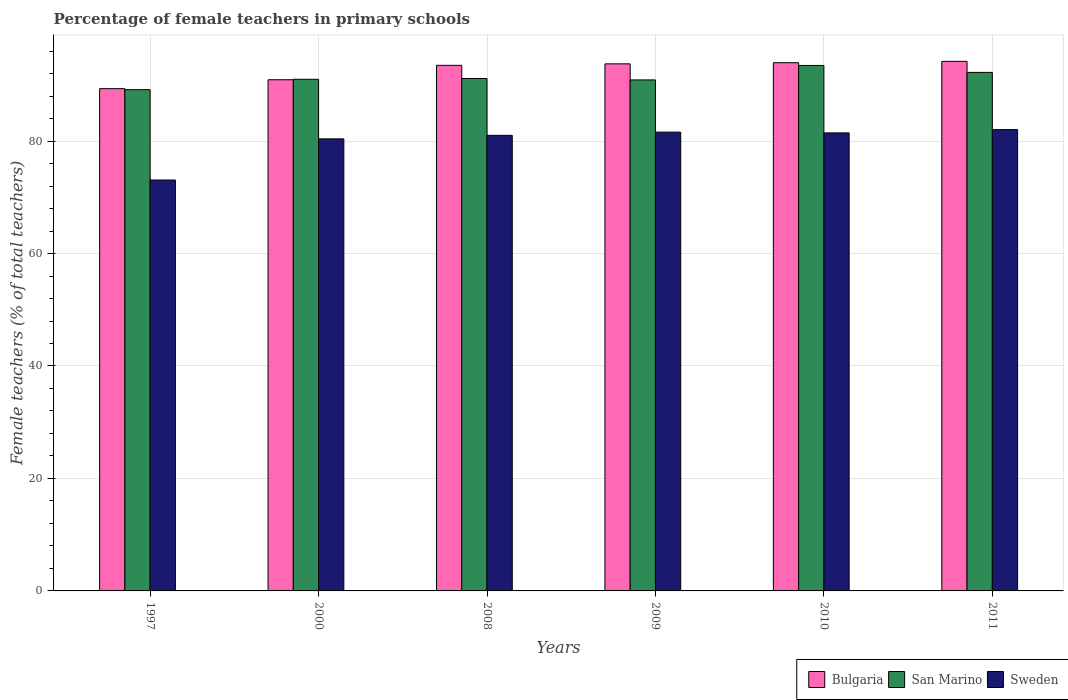Are the number of bars per tick equal to the number of legend labels?
Your answer should be compact. Yes. Are the number of bars on each tick of the X-axis equal?
Your answer should be very brief. Yes. How many bars are there on the 1st tick from the left?
Give a very brief answer. 3. What is the percentage of female teachers in Sweden in 1997?
Your answer should be compact. 73.07. Across all years, what is the maximum percentage of female teachers in Bulgaria?
Provide a succinct answer. 94.17. Across all years, what is the minimum percentage of female teachers in San Marino?
Ensure brevity in your answer.  89.14. In which year was the percentage of female teachers in Bulgaria maximum?
Offer a very short reply. 2011. In which year was the percentage of female teachers in Bulgaria minimum?
Your answer should be compact. 1997. What is the total percentage of female teachers in San Marino in the graph?
Offer a very short reply. 547.79. What is the difference between the percentage of female teachers in Sweden in 2010 and that in 2011?
Give a very brief answer. -0.58. What is the difference between the percentage of female teachers in Bulgaria in 1997 and the percentage of female teachers in Sweden in 2009?
Make the answer very short. 7.73. What is the average percentage of female teachers in Sweden per year?
Provide a short and direct response. 79.93. In the year 2011, what is the difference between the percentage of female teachers in San Marino and percentage of female teachers in Sweden?
Offer a very short reply. 10.18. In how many years, is the percentage of female teachers in San Marino greater than 64 %?
Ensure brevity in your answer.  6. What is the ratio of the percentage of female teachers in Sweden in 1997 to that in 2000?
Provide a succinct answer. 0.91. Is the percentage of female teachers in Bulgaria in 2000 less than that in 2009?
Provide a short and direct response. Yes. Is the difference between the percentage of female teachers in San Marino in 2000 and 2011 greater than the difference between the percentage of female teachers in Sweden in 2000 and 2011?
Your answer should be very brief. Yes. What is the difference between the highest and the second highest percentage of female teachers in Bulgaria?
Keep it short and to the point. 0.24. What is the difference between the highest and the lowest percentage of female teachers in San Marino?
Your answer should be very brief. 4.3. What does the 1st bar from the left in 2009 represents?
Make the answer very short. Bulgaria. Is it the case that in every year, the sum of the percentage of female teachers in San Marino and percentage of female teachers in Bulgaria is greater than the percentage of female teachers in Sweden?
Give a very brief answer. Yes. How many bars are there?
Provide a short and direct response. 18. What is the difference between two consecutive major ticks on the Y-axis?
Provide a short and direct response. 20. Does the graph contain any zero values?
Give a very brief answer. No. Does the graph contain grids?
Your answer should be compact. Yes. How many legend labels are there?
Keep it short and to the point. 3. How are the legend labels stacked?
Make the answer very short. Horizontal. What is the title of the graph?
Offer a very short reply. Percentage of female teachers in primary schools. What is the label or title of the X-axis?
Your answer should be compact. Years. What is the label or title of the Y-axis?
Give a very brief answer. Female teachers (% of total teachers). What is the Female teachers (% of total teachers) of Bulgaria in 1997?
Provide a succinct answer. 89.32. What is the Female teachers (% of total teachers) of San Marino in 1997?
Your answer should be very brief. 89.14. What is the Female teachers (% of total teachers) in Sweden in 1997?
Make the answer very short. 73.07. What is the Female teachers (% of total teachers) in Bulgaria in 2000?
Ensure brevity in your answer.  90.91. What is the Female teachers (% of total teachers) in San Marino in 2000?
Provide a succinct answer. 90.99. What is the Female teachers (% of total teachers) in Sweden in 2000?
Give a very brief answer. 80.39. What is the Female teachers (% of total teachers) of Bulgaria in 2008?
Give a very brief answer. 93.47. What is the Female teachers (% of total teachers) of San Marino in 2008?
Keep it short and to the point. 91.13. What is the Female teachers (% of total teachers) of Sweden in 2008?
Your answer should be very brief. 81.01. What is the Female teachers (% of total teachers) of Bulgaria in 2009?
Your response must be concise. 93.73. What is the Female teachers (% of total teachers) of San Marino in 2009?
Your answer should be compact. 90.87. What is the Female teachers (% of total teachers) of Sweden in 2009?
Your answer should be very brief. 81.59. What is the Female teachers (% of total teachers) of Bulgaria in 2010?
Make the answer very short. 93.93. What is the Female teachers (% of total teachers) in San Marino in 2010?
Your answer should be compact. 93.44. What is the Female teachers (% of total teachers) in Sweden in 2010?
Offer a terse response. 81.45. What is the Female teachers (% of total teachers) of Bulgaria in 2011?
Your answer should be compact. 94.17. What is the Female teachers (% of total teachers) in San Marino in 2011?
Your response must be concise. 92.21. What is the Female teachers (% of total teachers) of Sweden in 2011?
Provide a short and direct response. 82.04. Across all years, what is the maximum Female teachers (% of total teachers) in Bulgaria?
Ensure brevity in your answer.  94.17. Across all years, what is the maximum Female teachers (% of total teachers) in San Marino?
Provide a succinct answer. 93.44. Across all years, what is the maximum Female teachers (% of total teachers) in Sweden?
Offer a terse response. 82.04. Across all years, what is the minimum Female teachers (% of total teachers) in Bulgaria?
Ensure brevity in your answer.  89.32. Across all years, what is the minimum Female teachers (% of total teachers) in San Marino?
Offer a very short reply. 89.14. Across all years, what is the minimum Female teachers (% of total teachers) of Sweden?
Your answer should be very brief. 73.07. What is the total Female teachers (% of total teachers) of Bulgaria in the graph?
Your answer should be very brief. 555.53. What is the total Female teachers (% of total teachers) in San Marino in the graph?
Ensure brevity in your answer.  547.79. What is the total Female teachers (% of total teachers) of Sweden in the graph?
Your answer should be compact. 479.56. What is the difference between the Female teachers (% of total teachers) in Bulgaria in 1997 and that in 2000?
Offer a terse response. -1.59. What is the difference between the Female teachers (% of total teachers) in San Marino in 1997 and that in 2000?
Offer a very short reply. -1.85. What is the difference between the Female teachers (% of total teachers) in Sweden in 1997 and that in 2000?
Your answer should be very brief. -7.32. What is the difference between the Female teachers (% of total teachers) in Bulgaria in 1997 and that in 2008?
Make the answer very short. -4.15. What is the difference between the Female teachers (% of total teachers) in San Marino in 1997 and that in 2008?
Make the answer very short. -1.99. What is the difference between the Female teachers (% of total teachers) of Sweden in 1997 and that in 2008?
Offer a very short reply. -7.94. What is the difference between the Female teachers (% of total teachers) in Bulgaria in 1997 and that in 2009?
Offer a very short reply. -4.41. What is the difference between the Female teachers (% of total teachers) in San Marino in 1997 and that in 2009?
Ensure brevity in your answer.  -1.73. What is the difference between the Female teachers (% of total teachers) of Sweden in 1997 and that in 2009?
Your response must be concise. -8.52. What is the difference between the Female teachers (% of total teachers) of Bulgaria in 1997 and that in 2010?
Ensure brevity in your answer.  -4.61. What is the difference between the Female teachers (% of total teachers) of San Marino in 1997 and that in 2010?
Keep it short and to the point. -4.3. What is the difference between the Female teachers (% of total teachers) in Sweden in 1997 and that in 2010?
Provide a short and direct response. -8.38. What is the difference between the Female teachers (% of total teachers) in Bulgaria in 1997 and that in 2011?
Offer a terse response. -4.86. What is the difference between the Female teachers (% of total teachers) in San Marino in 1997 and that in 2011?
Offer a terse response. -3.07. What is the difference between the Female teachers (% of total teachers) in Sweden in 1997 and that in 2011?
Offer a very short reply. -8.96. What is the difference between the Female teachers (% of total teachers) of Bulgaria in 2000 and that in 2008?
Provide a succinct answer. -2.56. What is the difference between the Female teachers (% of total teachers) of San Marino in 2000 and that in 2008?
Your response must be concise. -0.14. What is the difference between the Female teachers (% of total teachers) of Sweden in 2000 and that in 2008?
Make the answer very short. -0.62. What is the difference between the Female teachers (% of total teachers) in Bulgaria in 2000 and that in 2009?
Ensure brevity in your answer.  -2.83. What is the difference between the Female teachers (% of total teachers) in San Marino in 2000 and that in 2009?
Your answer should be compact. 0.11. What is the difference between the Female teachers (% of total teachers) in Sweden in 2000 and that in 2009?
Ensure brevity in your answer.  -1.2. What is the difference between the Female teachers (% of total teachers) in Bulgaria in 2000 and that in 2010?
Keep it short and to the point. -3.03. What is the difference between the Female teachers (% of total teachers) in San Marino in 2000 and that in 2010?
Offer a terse response. -2.46. What is the difference between the Female teachers (% of total teachers) of Sweden in 2000 and that in 2010?
Offer a very short reply. -1.06. What is the difference between the Female teachers (% of total teachers) in Bulgaria in 2000 and that in 2011?
Ensure brevity in your answer.  -3.27. What is the difference between the Female teachers (% of total teachers) in San Marino in 2000 and that in 2011?
Your response must be concise. -1.23. What is the difference between the Female teachers (% of total teachers) in Sweden in 2000 and that in 2011?
Offer a very short reply. -1.65. What is the difference between the Female teachers (% of total teachers) in Bulgaria in 2008 and that in 2009?
Ensure brevity in your answer.  -0.27. What is the difference between the Female teachers (% of total teachers) of San Marino in 2008 and that in 2009?
Your answer should be compact. 0.26. What is the difference between the Female teachers (% of total teachers) of Sweden in 2008 and that in 2009?
Provide a succinct answer. -0.57. What is the difference between the Female teachers (% of total teachers) of Bulgaria in 2008 and that in 2010?
Offer a very short reply. -0.47. What is the difference between the Female teachers (% of total teachers) in San Marino in 2008 and that in 2010?
Provide a short and direct response. -2.31. What is the difference between the Female teachers (% of total teachers) of Sweden in 2008 and that in 2010?
Offer a terse response. -0.44. What is the difference between the Female teachers (% of total teachers) in Bulgaria in 2008 and that in 2011?
Give a very brief answer. -0.71. What is the difference between the Female teachers (% of total teachers) of San Marino in 2008 and that in 2011?
Provide a short and direct response. -1.08. What is the difference between the Female teachers (% of total teachers) in Sweden in 2008 and that in 2011?
Your response must be concise. -1.02. What is the difference between the Female teachers (% of total teachers) of Bulgaria in 2009 and that in 2010?
Make the answer very short. -0.2. What is the difference between the Female teachers (% of total teachers) of San Marino in 2009 and that in 2010?
Your answer should be compact. -2.57. What is the difference between the Female teachers (% of total teachers) of Sweden in 2009 and that in 2010?
Provide a short and direct response. 0.14. What is the difference between the Female teachers (% of total teachers) of Bulgaria in 2009 and that in 2011?
Your answer should be very brief. -0.44. What is the difference between the Female teachers (% of total teachers) of San Marino in 2009 and that in 2011?
Provide a succinct answer. -1.34. What is the difference between the Female teachers (% of total teachers) of Sweden in 2009 and that in 2011?
Provide a short and direct response. -0.45. What is the difference between the Female teachers (% of total teachers) in Bulgaria in 2010 and that in 2011?
Your answer should be very brief. -0.24. What is the difference between the Female teachers (% of total teachers) of San Marino in 2010 and that in 2011?
Your response must be concise. 1.23. What is the difference between the Female teachers (% of total teachers) of Sweden in 2010 and that in 2011?
Provide a short and direct response. -0.58. What is the difference between the Female teachers (% of total teachers) in Bulgaria in 1997 and the Female teachers (% of total teachers) in San Marino in 2000?
Keep it short and to the point. -1.67. What is the difference between the Female teachers (% of total teachers) of Bulgaria in 1997 and the Female teachers (% of total teachers) of Sweden in 2000?
Provide a succinct answer. 8.93. What is the difference between the Female teachers (% of total teachers) in San Marino in 1997 and the Female teachers (% of total teachers) in Sweden in 2000?
Ensure brevity in your answer.  8.75. What is the difference between the Female teachers (% of total teachers) in Bulgaria in 1997 and the Female teachers (% of total teachers) in San Marino in 2008?
Keep it short and to the point. -1.81. What is the difference between the Female teachers (% of total teachers) in Bulgaria in 1997 and the Female teachers (% of total teachers) in Sweden in 2008?
Your answer should be very brief. 8.3. What is the difference between the Female teachers (% of total teachers) in San Marino in 1997 and the Female teachers (% of total teachers) in Sweden in 2008?
Make the answer very short. 8.13. What is the difference between the Female teachers (% of total teachers) of Bulgaria in 1997 and the Female teachers (% of total teachers) of San Marino in 2009?
Provide a short and direct response. -1.55. What is the difference between the Female teachers (% of total teachers) in Bulgaria in 1997 and the Female teachers (% of total teachers) in Sweden in 2009?
Make the answer very short. 7.73. What is the difference between the Female teachers (% of total teachers) in San Marino in 1997 and the Female teachers (% of total teachers) in Sweden in 2009?
Offer a terse response. 7.55. What is the difference between the Female teachers (% of total teachers) of Bulgaria in 1997 and the Female teachers (% of total teachers) of San Marino in 2010?
Your answer should be compact. -4.12. What is the difference between the Female teachers (% of total teachers) of Bulgaria in 1997 and the Female teachers (% of total teachers) of Sweden in 2010?
Provide a succinct answer. 7.87. What is the difference between the Female teachers (% of total teachers) in San Marino in 1997 and the Female teachers (% of total teachers) in Sweden in 2010?
Make the answer very short. 7.69. What is the difference between the Female teachers (% of total teachers) in Bulgaria in 1997 and the Female teachers (% of total teachers) in San Marino in 2011?
Your answer should be very brief. -2.89. What is the difference between the Female teachers (% of total teachers) in Bulgaria in 1997 and the Female teachers (% of total teachers) in Sweden in 2011?
Keep it short and to the point. 7.28. What is the difference between the Female teachers (% of total teachers) in San Marino in 1997 and the Female teachers (% of total teachers) in Sweden in 2011?
Ensure brevity in your answer.  7.1. What is the difference between the Female teachers (% of total teachers) of Bulgaria in 2000 and the Female teachers (% of total teachers) of San Marino in 2008?
Give a very brief answer. -0.22. What is the difference between the Female teachers (% of total teachers) in Bulgaria in 2000 and the Female teachers (% of total teachers) in Sweden in 2008?
Provide a short and direct response. 9.89. What is the difference between the Female teachers (% of total teachers) of San Marino in 2000 and the Female teachers (% of total teachers) of Sweden in 2008?
Your response must be concise. 9.97. What is the difference between the Female teachers (% of total teachers) in Bulgaria in 2000 and the Female teachers (% of total teachers) in San Marino in 2009?
Your answer should be compact. 0.03. What is the difference between the Female teachers (% of total teachers) of Bulgaria in 2000 and the Female teachers (% of total teachers) of Sweden in 2009?
Your answer should be very brief. 9.32. What is the difference between the Female teachers (% of total teachers) in San Marino in 2000 and the Female teachers (% of total teachers) in Sweden in 2009?
Ensure brevity in your answer.  9.4. What is the difference between the Female teachers (% of total teachers) in Bulgaria in 2000 and the Female teachers (% of total teachers) in San Marino in 2010?
Offer a terse response. -2.54. What is the difference between the Female teachers (% of total teachers) in Bulgaria in 2000 and the Female teachers (% of total teachers) in Sweden in 2010?
Your answer should be very brief. 9.45. What is the difference between the Female teachers (% of total teachers) of San Marino in 2000 and the Female teachers (% of total teachers) of Sweden in 2010?
Offer a terse response. 9.53. What is the difference between the Female teachers (% of total teachers) in Bulgaria in 2000 and the Female teachers (% of total teachers) in San Marino in 2011?
Your answer should be very brief. -1.31. What is the difference between the Female teachers (% of total teachers) in Bulgaria in 2000 and the Female teachers (% of total teachers) in Sweden in 2011?
Your answer should be compact. 8.87. What is the difference between the Female teachers (% of total teachers) of San Marino in 2000 and the Female teachers (% of total teachers) of Sweden in 2011?
Give a very brief answer. 8.95. What is the difference between the Female teachers (% of total teachers) of Bulgaria in 2008 and the Female teachers (% of total teachers) of San Marino in 2009?
Provide a succinct answer. 2.59. What is the difference between the Female teachers (% of total teachers) of Bulgaria in 2008 and the Female teachers (% of total teachers) of Sweden in 2009?
Your answer should be compact. 11.88. What is the difference between the Female teachers (% of total teachers) of San Marino in 2008 and the Female teachers (% of total teachers) of Sweden in 2009?
Offer a very short reply. 9.54. What is the difference between the Female teachers (% of total teachers) in Bulgaria in 2008 and the Female teachers (% of total teachers) in San Marino in 2010?
Your response must be concise. 0.02. What is the difference between the Female teachers (% of total teachers) in Bulgaria in 2008 and the Female teachers (% of total teachers) in Sweden in 2010?
Provide a short and direct response. 12.01. What is the difference between the Female teachers (% of total teachers) of San Marino in 2008 and the Female teachers (% of total teachers) of Sweden in 2010?
Ensure brevity in your answer.  9.68. What is the difference between the Female teachers (% of total teachers) of Bulgaria in 2008 and the Female teachers (% of total teachers) of San Marino in 2011?
Your answer should be very brief. 1.25. What is the difference between the Female teachers (% of total teachers) of Bulgaria in 2008 and the Female teachers (% of total teachers) of Sweden in 2011?
Your response must be concise. 11.43. What is the difference between the Female teachers (% of total teachers) in San Marino in 2008 and the Female teachers (% of total teachers) in Sweden in 2011?
Ensure brevity in your answer.  9.09. What is the difference between the Female teachers (% of total teachers) in Bulgaria in 2009 and the Female teachers (% of total teachers) in San Marino in 2010?
Your answer should be very brief. 0.29. What is the difference between the Female teachers (% of total teachers) of Bulgaria in 2009 and the Female teachers (% of total teachers) of Sweden in 2010?
Offer a very short reply. 12.28. What is the difference between the Female teachers (% of total teachers) of San Marino in 2009 and the Female teachers (% of total teachers) of Sweden in 2010?
Give a very brief answer. 9.42. What is the difference between the Female teachers (% of total teachers) of Bulgaria in 2009 and the Female teachers (% of total teachers) of San Marino in 2011?
Ensure brevity in your answer.  1.52. What is the difference between the Female teachers (% of total teachers) in Bulgaria in 2009 and the Female teachers (% of total teachers) in Sweden in 2011?
Provide a succinct answer. 11.69. What is the difference between the Female teachers (% of total teachers) of San Marino in 2009 and the Female teachers (% of total teachers) of Sweden in 2011?
Offer a very short reply. 8.84. What is the difference between the Female teachers (% of total teachers) of Bulgaria in 2010 and the Female teachers (% of total teachers) of San Marino in 2011?
Offer a very short reply. 1.72. What is the difference between the Female teachers (% of total teachers) of Bulgaria in 2010 and the Female teachers (% of total teachers) of Sweden in 2011?
Your answer should be compact. 11.9. What is the difference between the Female teachers (% of total teachers) in San Marino in 2010 and the Female teachers (% of total teachers) in Sweden in 2011?
Your answer should be very brief. 11.41. What is the average Female teachers (% of total teachers) in Bulgaria per year?
Provide a succinct answer. 92.59. What is the average Female teachers (% of total teachers) in San Marino per year?
Offer a very short reply. 91.3. What is the average Female teachers (% of total teachers) in Sweden per year?
Offer a very short reply. 79.93. In the year 1997, what is the difference between the Female teachers (% of total teachers) in Bulgaria and Female teachers (% of total teachers) in San Marino?
Keep it short and to the point. 0.18. In the year 1997, what is the difference between the Female teachers (% of total teachers) in Bulgaria and Female teachers (% of total teachers) in Sweden?
Offer a very short reply. 16.25. In the year 1997, what is the difference between the Female teachers (% of total teachers) of San Marino and Female teachers (% of total teachers) of Sweden?
Offer a terse response. 16.07. In the year 2000, what is the difference between the Female teachers (% of total teachers) of Bulgaria and Female teachers (% of total teachers) of San Marino?
Make the answer very short. -0.08. In the year 2000, what is the difference between the Female teachers (% of total teachers) in Bulgaria and Female teachers (% of total teachers) in Sweden?
Offer a very short reply. 10.52. In the year 2000, what is the difference between the Female teachers (% of total teachers) of San Marino and Female teachers (% of total teachers) of Sweden?
Provide a short and direct response. 10.6. In the year 2008, what is the difference between the Female teachers (% of total teachers) of Bulgaria and Female teachers (% of total teachers) of San Marino?
Your answer should be very brief. 2.34. In the year 2008, what is the difference between the Female teachers (% of total teachers) in Bulgaria and Female teachers (% of total teachers) in Sweden?
Ensure brevity in your answer.  12.45. In the year 2008, what is the difference between the Female teachers (% of total teachers) of San Marino and Female teachers (% of total teachers) of Sweden?
Keep it short and to the point. 10.11. In the year 2009, what is the difference between the Female teachers (% of total teachers) in Bulgaria and Female teachers (% of total teachers) in San Marino?
Offer a terse response. 2.86. In the year 2009, what is the difference between the Female teachers (% of total teachers) of Bulgaria and Female teachers (% of total teachers) of Sweden?
Offer a very short reply. 12.14. In the year 2009, what is the difference between the Female teachers (% of total teachers) of San Marino and Female teachers (% of total teachers) of Sweden?
Make the answer very short. 9.28. In the year 2010, what is the difference between the Female teachers (% of total teachers) in Bulgaria and Female teachers (% of total teachers) in San Marino?
Your answer should be compact. 0.49. In the year 2010, what is the difference between the Female teachers (% of total teachers) in Bulgaria and Female teachers (% of total teachers) in Sweden?
Give a very brief answer. 12.48. In the year 2010, what is the difference between the Female teachers (% of total teachers) of San Marino and Female teachers (% of total teachers) of Sweden?
Offer a very short reply. 11.99. In the year 2011, what is the difference between the Female teachers (% of total teachers) of Bulgaria and Female teachers (% of total teachers) of San Marino?
Ensure brevity in your answer.  1.96. In the year 2011, what is the difference between the Female teachers (% of total teachers) of Bulgaria and Female teachers (% of total teachers) of Sweden?
Make the answer very short. 12.14. In the year 2011, what is the difference between the Female teachers (% of total teachers) of San Marino and Female teachers (% of total teachers) of Sweden?
Offer a terse response. 10.18. What is the ratio of the Female teachers (% of total teachers) in Bulgaria in 1997 to that in 2000?
Make the answer very short. 0.98. What is the ratio of the Female teachers (% of total teachers) in San Marino in 1997 to that in 2000?
Provide a short and direct response. 0.98. What is the ratio of the Female teachers (% of total teachers) in Sweden in 1997 to that in 2000?
Make the answer very short. 0.91. What is the ratio of the Female teachers (% of total teachers) of Bulgaria in 1997 to that in 2008?
Provide a short and direct response. 0.96. What is the ratio of the Female teachers (% of total teachers) of San Marino in 1997 to that in 2008?
Ensure brevity in your answer.  0.98. What is the ratio of the Female teachers (% of total teachers) of Sweden in 1997 to that in 2008?
Your response must be concise. 0.9. What is the ratio of the Female teachers (% of total teachers) of Bulgaria in 1997 to that in 2009?
Provide a succinct answer. 0.95. What is the ratio of the Female teachers (% of total teachers) of San Marino in 1997 to that in 2009?
Offer a very short reply. 0.98. What is the ratio of the Female teachers (% of total teachers) in Sweden in 1997 to that in 2009?
Give a very brief answer. 0.9. What is the ratio of the Female teachers (% of total teachers) in Bulgaria in 1997 to that in 2010?
Your response must be concise. 0.95. What is the ratio of the Female teachers (% of total teachers) of San Marino in 1997 to that in 2010?
Offer a terse response. 0.95. What is the ratio of the Female teachers (% of total teachers) in Sweden in 1997 to that in 2010?
Provide a short and direct response. 0.9. What is the ratio of the Female teachers (% of total teachers) of Bulgaria in 1997 to that in 2011?
Offer a very short reply. 0.95. What is the ratio of the Female teachers (% of total teachers) in San Marino in 1997 to that in 2011?
Your answer should be compact. 0.97. What is the ratio of the Female teachers (% of total teachers) in Sweden in 1997 to that in 2011?
Your response must be concise. 0.89. What is the ratio of the Female teachers (% of total teachers) of Bulgaria in 2000 to that in 2008?
Offer a terse response. 0.97. What is the ratio of the Female teachers (% of total teachers) in Bulgaria in 2000 to that in 2009?
Give a very brief answer. 0.97. What is the ratio of the Female teachers (% of total teachers) in Bulgaria in 2000 to that in 2010?
Keep it short and to the point. 0.97. What is the ratio of the Female teachers (% of total teachers) of San Marino in 2000 to that in 2010?
Provide a short and direct response. 0.97. What is the ratio of the Female teachers (% of total teachers) in Bulgaria in 2000 to that in 2011?
Ensure brevity in your answer.  0.97. What is the ratio of the Female teachers (% of total teachers) in San Marino in 2000 to that in 2011?
Provide a succinct answer. 0.99. What is the ratio of the Female teachers (% of total teachers) in Sweden in 2000 to that in 2011?
Keep it short and to the point. 0.98. What is the ratio of the Female teachers (% of total teachers) of Bulgaria in 2008 to that in 2009?
Your response must be concise. 1. What is the ratio of the Female teachers (% of total teachers) of Bulgaria in 2008 to that in 2010?
Your answer should be very brief. 0.99. What is the ratio of the Female teachers (% of total teachers) in San Marino in 2008 to that in 2010?
Keep it short and to the point. 0.98. What is the ratio of the Female teachers (% of total teachers) in Sweden in 2008 to that in 2010?
Make the answer very short. 0.99. What is the ratio of the Female teachers (% of total teachers) of Sweden in 2008 to that in 2011?
Offer a terse response. 0.99. What is the ratio of the Female teachers (% of total teachers) in Bulgaria in 2009 to that in 2010?
Keep it short and to the point. 1. What is the ratio of the Female teachers (% of total teachers) in San Marino in 2009 to that in 2010?
Keep it short and to the point. 0.97. What is the ratio of the Female teachers (% of total teachers) of Sweden in 2009 to that in 2010?
Provide a short and direct response. 1. What is the ratio of the Female teachers (% of total teachers) in San Marino in 2009 to that in 2011?
Your answer should be compact. 0.99. What is the ratio of the Female teachers (% of total teachers) of Sweden in 2009 to that in 2011?
Your answer should be compact. 0.99. What is the ratio of the Female teachers (% of total teachers) in Bulgaria in 2010 to that in 2011?
Offer a terse response. 1. What is the ratio of the Female teachers (% of total teachers) in San Marino in 2010 to that in 2011?
Your answer should be very brief. 1.01. What is the difference between the highest and the second highest Female teachers (% of total teachers) in Bulgaria?
Make the answer very short. 0.24. What is the difference between the highest and the second highest Female teachers (% of total teachers) of San Marino?
Provide a succinct answer. 1.23. What is the difference between the highest and the second highest Female teachers (% of total teachers) in Sweden?
Offer a very short reply. 0.45. What is the difference between the highest and the lowest Female teachers (% of total teachers) of Bulgaria?
Make the answer very short. 4.86. What is the difference between the highest and the lowest Female teachers (% of total teachers) of San Marino?
Your response must be concise. 4.3. What is the difference between the highest and the lowest Female teachers (% of total teachers) of Sweden?
Your answer should be compact. 8.96. 